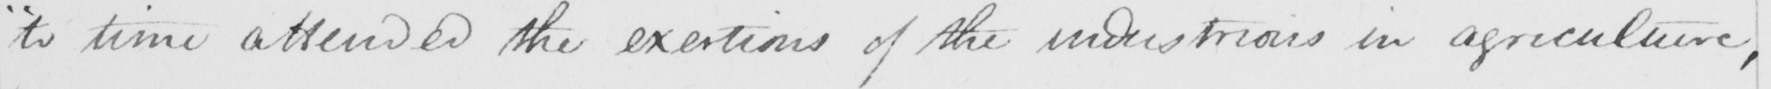What text is written in this handwritten line? " to time attended the exertions of the industrious in agriculture , 